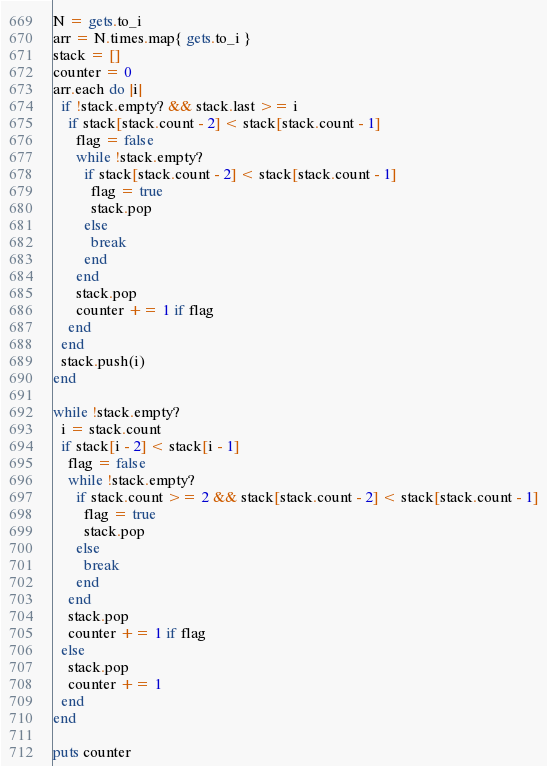<code> <loc_0><loc_0><loc_500><loc_500><_Ruby_>N = gets.to_i
arr = N.times.map{ gets.to_i }
stack = []
counter = 0
arr.each do |i|
  if !stack.empty? && stack.last >= i
    if stack[stack.count - 2] < stack[stack.count - 1]
      flag = false
      while !stack.empty?
        if stack[stack.count - 2] < stack[stack.count - 1]
          flag = true
          stack.pop
        else
          break
        end
      end
      stack.pop
      counter += 1 if flag
    end
  end
  stack.push(i)
end

while !stack.empty?
  i = stack.count
  if stack[i - 2] < stack[i - 1]
    flag = false
    while !stack.empty?
      if stack.count >= 2 && stack[stack.count - 2] < stack[stack.count - 1]
        flag = true
        stack.pop
      else
        break
      end
    end
    stack.pop
    counter += 1 if flag
  else
    stack.pop
    counter += 1
  end
end

puts counter</code> 